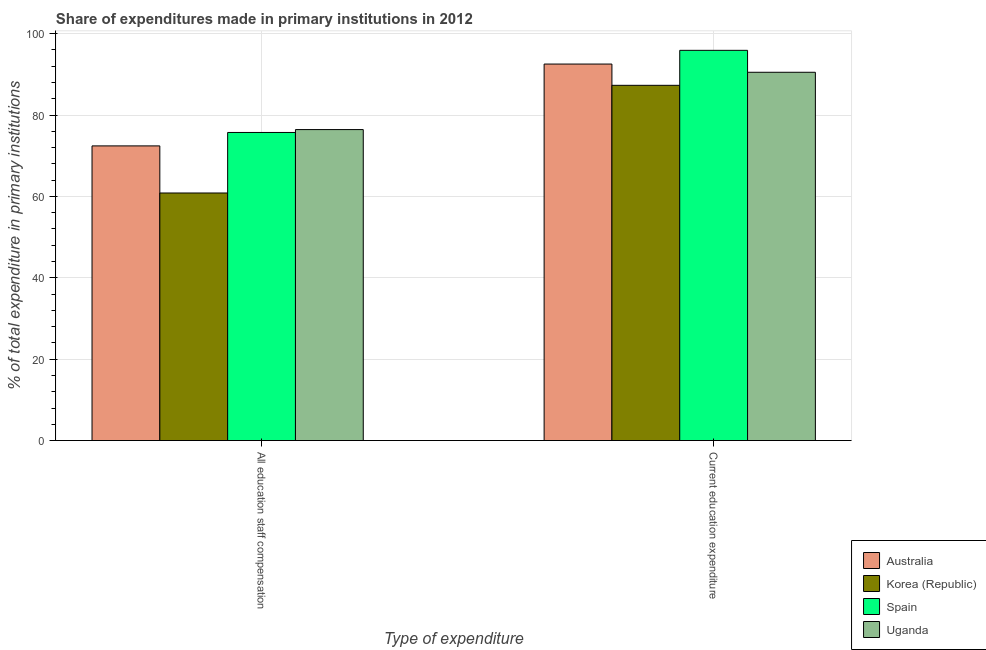Are the number of bars per tick equal to the number of legend labels?
Offer a very short reply. Yes. Are the number of bars on each tick of the X-axis equal?
Your answer should be very brief. Yes. How many bars are there on the 1st tick from the left?
Offer a terse response. 4. What is the label of the 2nd group of bars from the left?
Your answer should be very brief. Current education expenditure. What is the expenditure in staff compensation in Spain?
Offer a very short reply. 75.72. Across all countries, what is the maximum expenditure in education?
Offer a terse response. 95.91. Across all countries, what is the minimum expenditure in staff compensation?
Your answer should be very brief. 60.85. In which country was the expenditure in staff compensation maximum?
Offer a terse response. Uganda. What is the total expenditure in staff compensation in the graph?
Offer a terse response. 285.43. What is the difference between the expenditure in staff compensation in Australia and that in Spain?
Provide a short and direct response. -3.3. What is the difference between the expenditure in education in Korea (Republic) and the expenditure in staff compensation in Spain?
Your response must be concise. 11.58. What is the average expenditure in education per country?
Provide a succinct answer. 91.57. What is the difference between the expenditure in staff compensation and expenditure in education in Korea (Republic)?
Your answer should be compact. -26.46. In how many countries, is the expenditure in staff compensation greater than 12 %?
Offer a very short reply. 4. What is the ratio of the expenditure in education in Spain to that in Korea (Republic)?
Provide a short and direct response. 1.1. Is the expenditure in staff compensation in Spain less than that in Uganda?
Your response must be concise. Yes. In how many countries, is the expenditure in staff compensation greater than the average expenditure in staff compensation taken over all countries?
Your answer should be very brief. 3. What does the 1st bar from the left in Current education expenditure represents?
Your response must be concise. Australia. Are the values on the major ticks of Y-axis written in scientific E-notation?
Your answer should be very brief. No. Does the graph contain any zero values?
Provide a succinct answer. No. How many legend labels are there?
Offer a very short reply. 4. How are the legend labels stacked?
Your response must be concise. Vertical. What is the title of the graph?
Your answer should be very brief. Share of expenditures made in primary institutions in 2012. What is the label or title of the X-axis?
Provide a succinct answer. Type of expenditure. What is the label or title of the Y-axis?
Provide a short and direct response. % of total expenditure in primary institutions. What is the % of total expenditure in primary institutions of Australia in All education staff compensation?
Ensure brevity in your answer.  72.42. What is the % of total expenditure in primary institutions in Korea (Republic) in All education staff compensation?
Give a very brief answer. 60.85. What is the % of total expenditure in primary institutions in Spain in All education staff compensation?
Ensure brevity in your answer.  75.72. What is the % of total expenditure in primary institutions in Uganda in All education staff compensation?
Provide a short and direct response. 76.43. What is the % of total expenditure in primary institutions of Australia in Current education expenditure?
Provide a short and direct response. 92.54. What is the % of total expenditure in primary institutions in Korea (Republic) in Current education expenditure?
Your answer should be very brief. 87.31. What is the % of total expenditure in primary institutions of Spain in Current education expenditure?
Make the answer very short. 95.91. What is the % of total expenditure in primary institutions of Uganda in Current education expenditure?
Provide a short and direct response. 90.52. Across all Type of expenditure, what is the maximum % of total expenditure in primary institutions in Australia?
Give a very brief answer. 92.54. Across all Type of expenditure, what is the maximum % of total expenditure in primary institutions in Korea (Republic)?
Ensure brevity in your answer.  87.31. Across all Type of expenditure, what is the maximum % of total expenditure in primary institutions of Spain?
Your response must be concise. 95.91. Across all Type of expenditure, what is the maximum % of total expenditure in primary institutions in Uganda?
Keep it short and to the point. 90.52. Across all Type of expenditure, what is the minimum % of total expenditure in primary institutions in Australia?
Give a very brief answer. 72.42. Across all Type of expenditure, what is the minimum % of total expenditure in primary institutions in Korea (Republic)?
Keep it short and to the point. 60.85. Across all Type of expenditure, what is the minimum % of total expenditure in primary institutions in Spain?
Make the answer very short. 75.72. Across all Type of expenditure, what is the minimum % of total expenditure in primary institutions in Uganda?
Ensure brevity in your answer.  76.43. What is the total % of total expenditure in primary institutions of Australia in the graph?
Your answer should be compact. 164.96. What is the total % of total expenditure in primary institutions of Korea (Republic) in the graph?
Keep it short and to the point. 148.16. What is the total % of total expenditure in primary institutions of Spain in the graph?
Keep it short and to the point. 171.63. What is the total % of total expenditure in primary institutions of Uganda in the graph?
Offer a terse response. 166.95. What is the difference between the % of total expenditure in primary institutions in Australia in All education staff compensation and that in Current education expenditure?
Give a very brief answer. -20.12. What is the difference between the % of total expenditure in primary institutions of Korea (Republic) in All education staff compensation and that in Current education expenditure?
Your response must be concise. -26.46. What is the difference between the % of total expenditure in primary institutions in Spain in All education staff compensation and that in Current education expenditure?
Offer a very short reply. -20.18. What is the difference between the % of total expenditure in primary institutions of Uganda in All education staff compensation and that in Current education expenditure?
Provide a succinct answer. -14.09. What is the difference between the % of total expenditure in primary institutions of Australia in All education staff compensation and the % of total expenditure in primary institutions of Korea (Republic) in Current education expenditure?
Give a very brief answer. -14.89. What is the difference between the % of total expenditure in primary institutions of Australia in All education staff compensation and the % of total expenditure in primary institutions of Spain in Current education expenditure?
Make the answer very short. -23.49. What is the difference between the % of total expenditure in primary institutions in Australia in All education staff compensation and the % of total expenditure in primary institutions in Uganda in Current education expenditure?
Ensure brevity in your answer.  -18.1. What is the difference between the % of total expenditure in primary institutions in Korea (Republic) in All education staff compensation and the % of total expenditure in primary institutions in Spain in Current education expenditure?
Your answer should be compact. -35.06. What is the difference between the % of total expenditure in primary institutions in Korea (Republic) in All education staff compensation and the % of total expenditure in primary institutions in Uganda in Current education expenditure?
Offer a terse response. -29.67. What is the difference between the % of total expenditure in primary institutions of Spain in All education staff compensation and the % of total expenditure in primary institutions of Uganda in Current education expenditure?
Your answer should be compact. -14.79. What is the average % of total expenditure in primary institutions of Australia per Type of expenditure?
Provide a short and direct response. 82.48. What is the average % of total expenditure in primary institutions in Korea (Republic) per Type of expenditure?
Your answer should be very brief. 74.08. What is the average % of total expenditure in primary institutions of Spain per Type of expenditure?
Give a very brief answer. 85.82. What is the average % of total expenditure in primary institutions of Uganda per Type of expenditure?
Offer a terse response. 83.47. What is the difference between the % of total expenditure in primary institutions in Australia and % of total expenditure in primary institutions in Korea (Republic) in All education staff compensation?
Make the answer very short. 11.57. What is the difference between the % of total expenditure in primary institutions in Australia and % of total expenditure in primary institutions in Spain in All education staff compensation?
Provide a succinct answer. -3.3. What is the difference between the % of total expenditure in primary institutions of Australia and % of total expenditure in primary institutions of Uganda in All education staff compensation?
Your response must be concise. -4.01. What is the difference between the % of total expenditure in primary institutions in Korea (Republic) and % of total expenditure in primary institutions in Spain in All education staff compensation?
Your answer should be very brief. -14.87. What is the difference between the % of total expenditure in primary institutions of Korea (Republic) and % of total expenditure in primary institutions of Uganda in All education staff compensation?
Make the answer very short. -15.58. What is the difference between the % of total expenditure in primary institutions in Spain and % of total expenditure in primary institutions in Uganda in All education staff compensation?
Provide a succinct answer. -0.71. What is the difference between the % of total expenditure in primary institutions of Australia and % of total expenditure in primary institutions of Korea (Republic) in Current education expenditure?
Offer a very short reply. 5.23. What is the difference between the % of total expenditure in primary institutions in Australia and % of total expenditure in primary institutions in Spain in Current education expenditure?
Offer a very short reply. -3.37. What is the difference between the % of total expenditure in primary institutions of Australia and % of total expenditure in primary institutions of Uganda in Current education expenditure?
Give a very brief answer. 2.02. What is the difference between the % of total expenditure in primary institutions in Korea (Republic) and % of total expenditure in primary institutions in Spain in Current education expenditure?
Make the answer very short. -8.6. What is the difference between the % of total expenditure in primary institutions of Korea (Republic) and % of total expenditure in primary institutions of Uganda in Current education expenditure?
Give a very brief answer. -3.21. What is the difference between the % of total expenditure in primary institutions of Spain and % of total expenditure in primary institutions of Uganda in Current education expenditure?
Your answer should be compact. 5.39. What is the ratio of the % of total expenditure in primary institutions in Australia in All education staff compensation to that in Current education expenditure?
Offer a terse response. 0.78. What is the ratio of the % of total expenditure in primary institutions in Korea (Republic) in All education staff compensation to that in Current education expenditure?
Make the answer very short. 0.7. What is the ratio of the % of total expenditure in primary institutions in Spain in All education staff compensation to that in Current education expenditure?
Your answer should be compact. 0.79. What is the ratio of the % of total expenditure in primary institutions of Uganda in All education staff compensation to that in Current education expenditure?
Give a very brief answer. 0.84. What is the difference between the highest and the second highest % of total expenditure in primary institutions of Australia?
Your answer should be very brief. 20.12. What is the difference between the highest and the second highest % of total expenditure in primary institutions of Korea (Republic)?
Your response must be concise. 26.46. What is the difference between the highest and the second highest % of total expenditure in primary institutions of Spain?
Your answer should be compact. 20.18. What is the difference between the highest and the second highest % of total expenditure in primary institutions of Uganda?
Make the answer very short. 14.09. What is the difference between the highest and the lowest % of total expenditure in primary institutions of Australia?
Give a very brief answer. 20.12. What is the difference between the highest and the lowest % of total expenditure in primary institutions in Korea (Republic)?
Provide a short and direct response. 26.46. What is the difference between the highest and the lowest % of total expenditure in primary institutions in Spain?
Provide a short and direct response. 20.18. What is the difference between the highest and the lowest % of total expenditure in primary institutions of Uganda?
Make the answer very short. 14.09. 